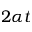Convert formula to latex. <formula><loc_0><loc_0><loc_500><loc_500>2 \alpha t</formula> 